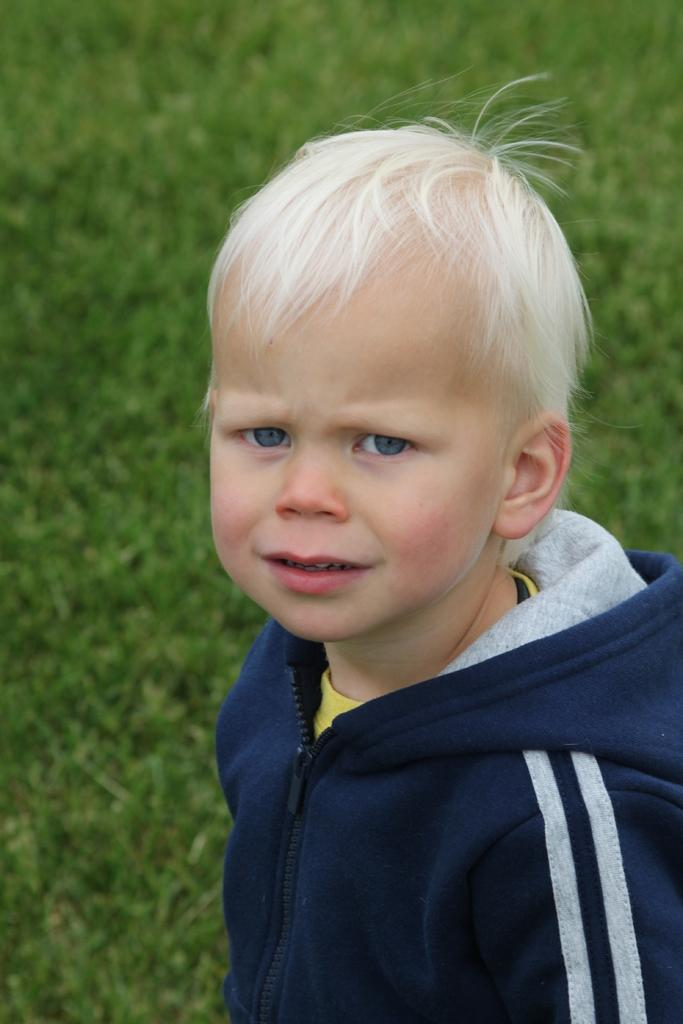What is there is a boy in the foreground of the image, what is he wearing? The boy is wearing a blue sweater. What can be seen in the background of the image? There is grass visible in the background of the image. How does the boy sort the grass in the image? There is no indication in the image that the boy is sorting grass, as he is simply standing in the foreground wearing a blue sweater. 